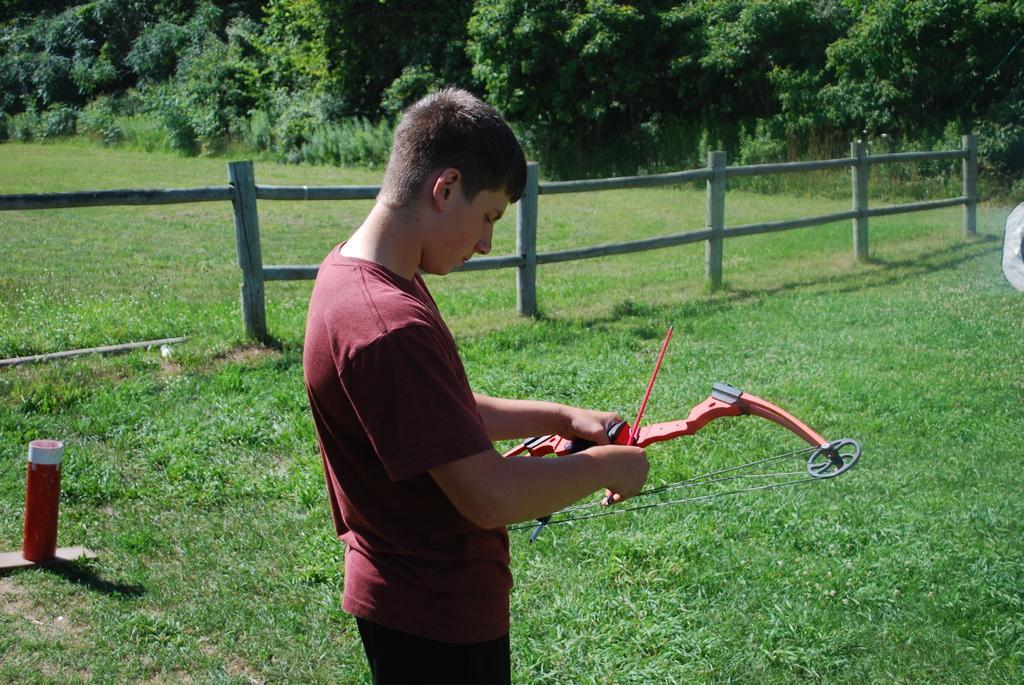How would you summarize this image in a sentence or two? In this image we can see a person wearing red color T-shirt standing and holding archery in his hands which is in red color and on left side of the image there is wooden fencing and some trees. 